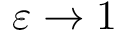Convert formula to latex. <formula><loc_0><loc_0><loc_500><loc_500>\varepsilon \rightarrow 1</formula> 